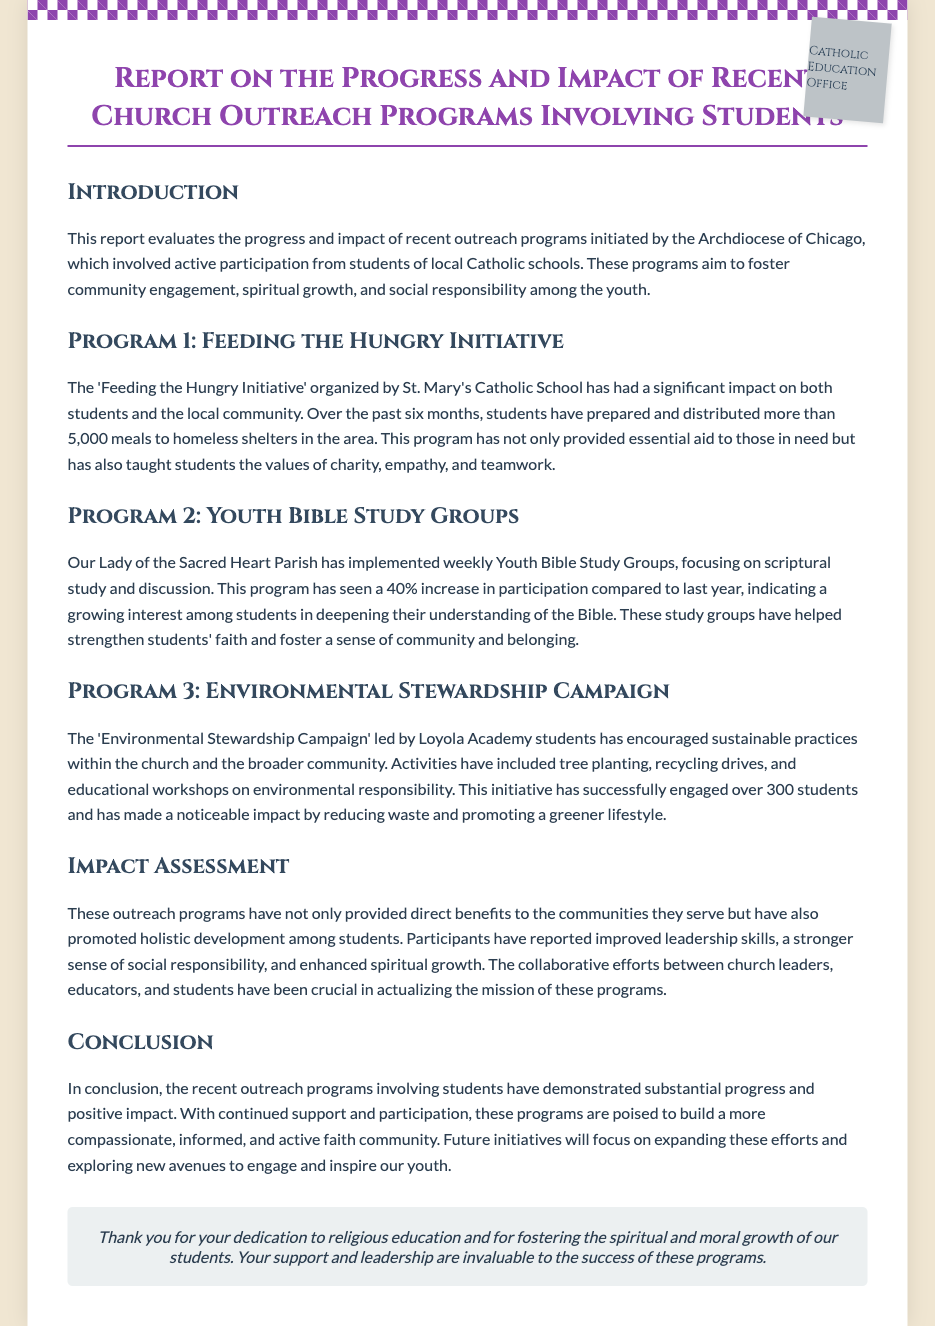What is the title of the report? The title of the report is prominently displayed at the top of the document.
Answer: Report on the Progress and Impact of Recent Church Outreach Programs Involving Students How many meals were prepared and distributed in the Feeding the Hungry Initiative? The document states the specific number of meals as part of this initiative.
Answer: More than 5,000 meals What percentage increase in participation was observed in the Youth Bible Study Groups? The document explicitly mentions the percentage change in participation from the previous year.
Answer: 40% Which school organized the Feeding the Hungry Initiative? The document identifies the school responsible for this outreach program.
Answer: St. Mary's Catholic School What type of campaign did Loyola Academy students lead? The document details the nature of the initiative led by Loyola Academy students.
Answer: Environmental Stewardship Campaign What are two values taught to students through the Feeding the Hungry Initiative? The report describes the values that students learned through their participation.
Answer: Charity, empathy What impact has the outreach program had on student skills? The document includes an assessment of the skills developed among participating students.
Answer: Improved leadership skills How many students engaged in the Environmental Stewardship Campaign? The participation figure for this campaign is provided in the report.
Answer: Over 300 students What is the main goal of the outreach programs mentioned in the document? The document outlines the overarching aim of the outreach programs.
Answer: Foster community engagement, spiritual growth, and social responsibility 